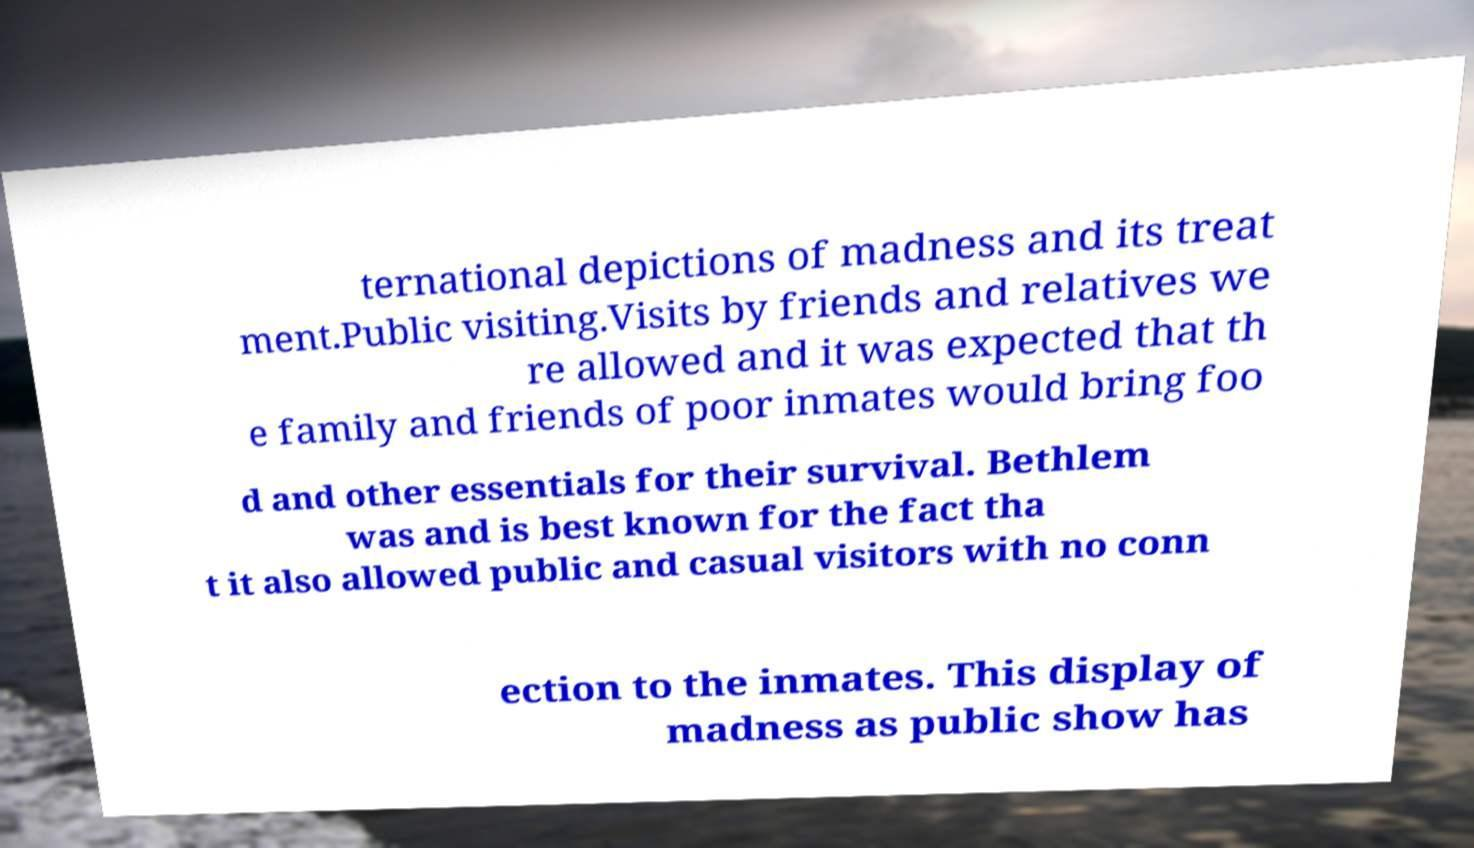What messages or text are displayed in this image? I need them in a readable, typed format. ternational depictions of madness and its treat ment.Public visiting.Visits by friends and relatives we re allowed and it was expected that th e family and friends of poor inmates would bring foo d and other essentials for their survival. Bethlem was and is best known for the fact tha t it also allowed public and casual visitors with no conn ection to the inmates. This display of madness as public show has 